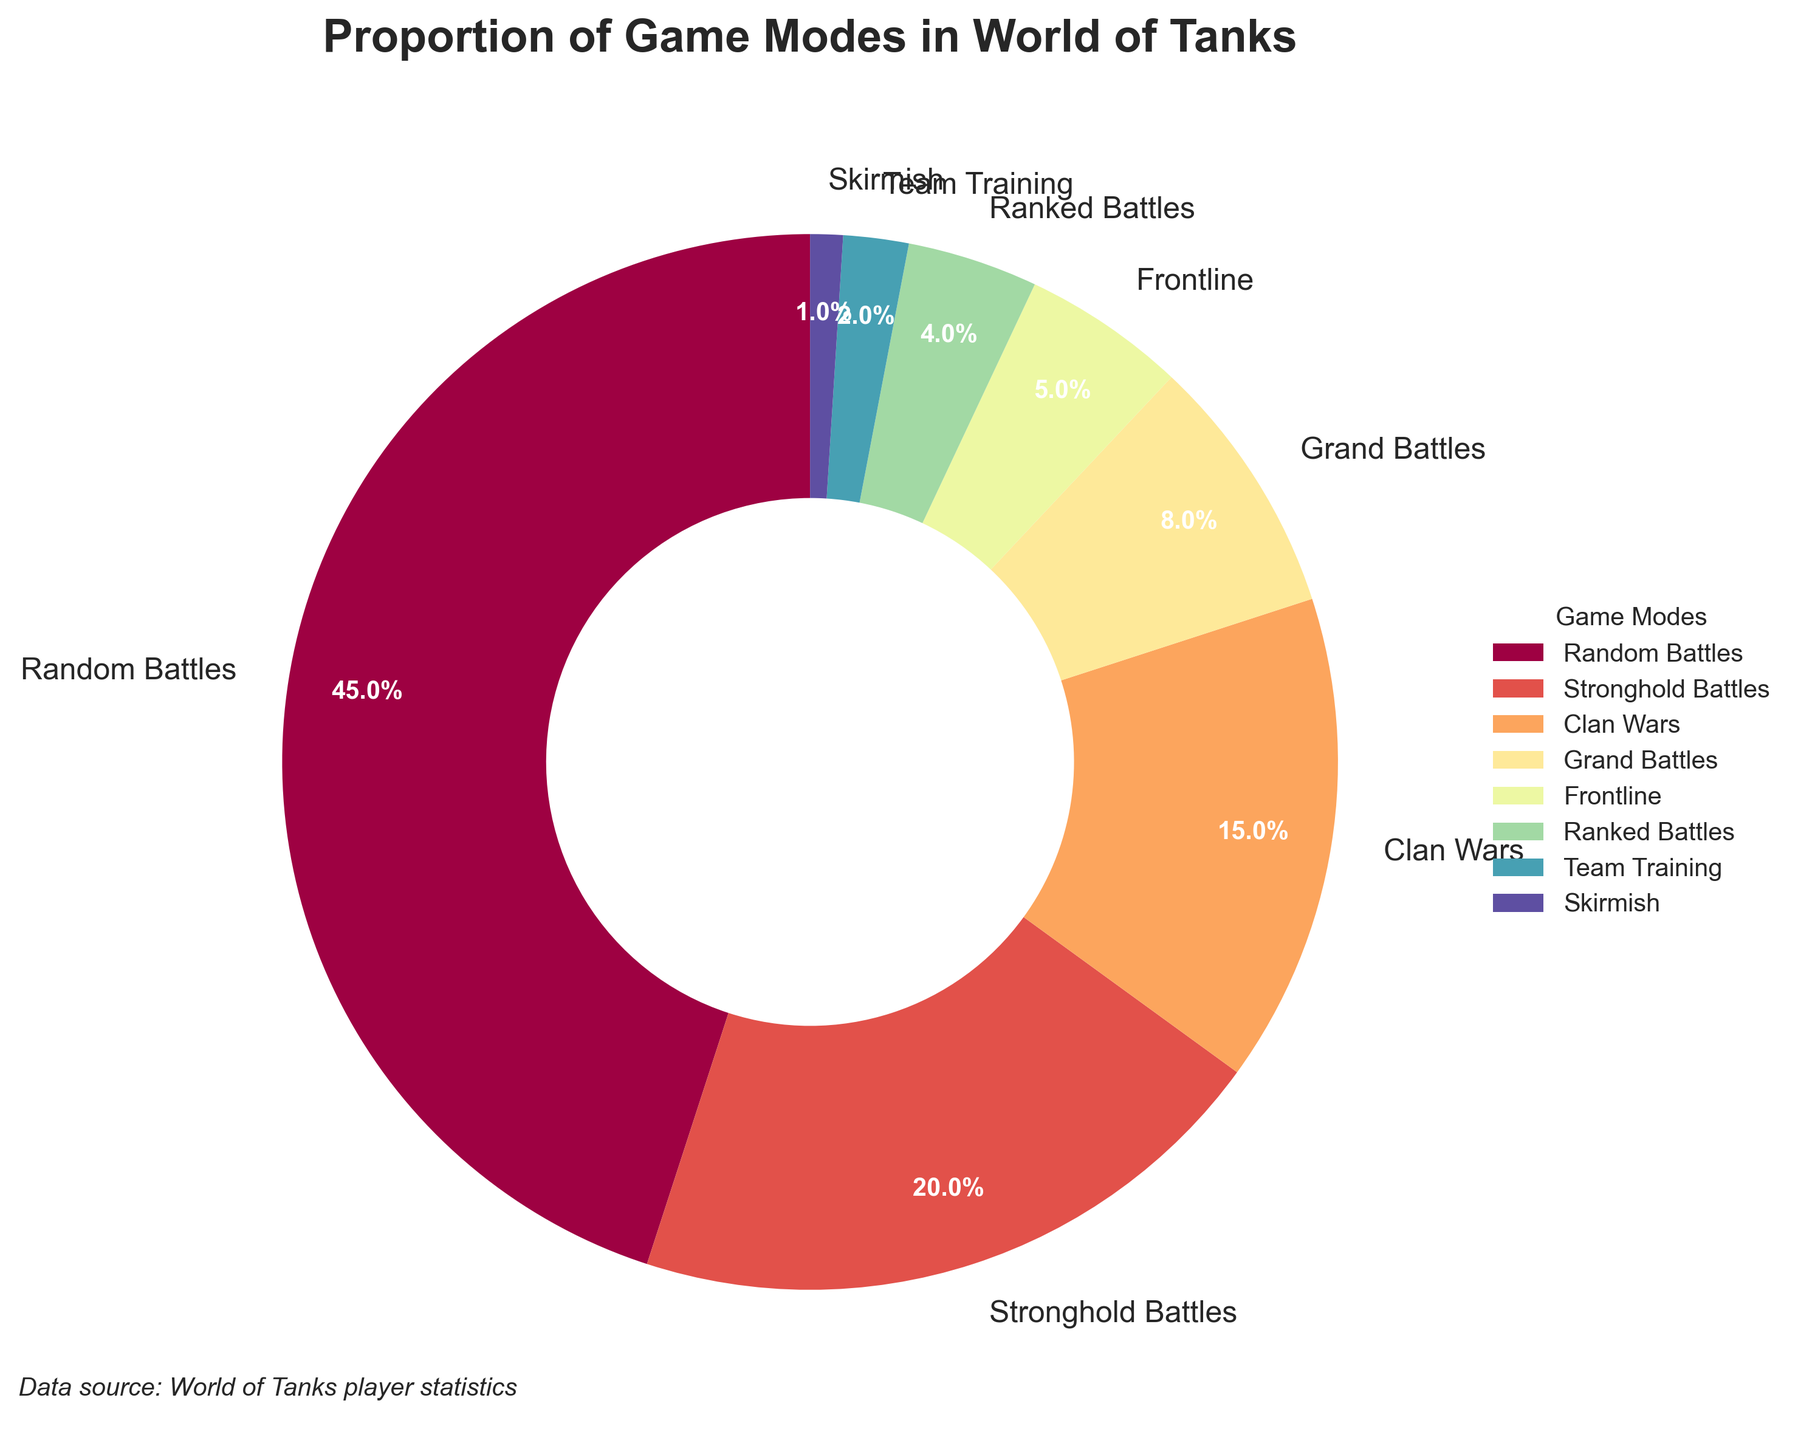What proportion of game modes does 'Random Battles' represent? The 'Random Battles' section of the pie chart represents 45% of the total game modes played. The chart shows the proportion directly.
Answer: 45% Which game mode has the smallest proportion and what is its percentage? The section of the pie chart labeled 'Skirmish' represents the smallest proportion of game modes played, which is 1%.
Answer: Skirmish, 1% How does the proportion of 'Stronghold Battles' compare to 'Clan Wars'? The 'Stronghold Battles' section represents 20% while 'Clan Wars' represents 15%. Thus, 'Stronghold Battles' account for a larger proportion than 'Clan Wars'.
Answer: Stronghold Battles > Clan Wars What is the combined percentage of 'Ranked Battles' and 'Team Training'? 'Ranked Battles' represent 4% and 'Team Training' represents 2%, so the combined percentage is 4% + 2% = 6%.
Answer: 6% If 'Random Battles' and 'Stronghold Battles' are combined, what percentage of game modes do they represent? Random Battles' represent 45% and 'Stronghold Battles' represent 20%. When combined, they represent 45% + 20% = 65%.
Answer: 65% Which game mode has a higher percentage, 'Frontline' or 'Grand Battles'? 'Grand Battles' are represented by 8% while 'Frontline' is represented by 5%. Therefore, 'Grand Battles' have a higher percentage.
Answer: Grand Battles What is the median percentage value among the game modes? The percentages are: 45, 20, 15, 8, 5, 4, 2, 1. When ordered, the middle two values are 8 and 5. The median is (8 + 5)/2 = 6.5.
Answer: 6.5% What color represents 'Random Battles' in the pie chart? In the pie chart, different game modes are represented by different colors. The 'Random Battles' section is the largest and is usually highlighted with the first color in the colormap applied, often seen in a prominent color like red or another easily distinguishable color.
Answer: Red (or prominent color) Which game modes combined make up less than 10% of the game play? 'Ranked Battles' (4%), 'Team Training' (2%), and 'Skirmish' (1%) combined sum up to 4% + 2% + 1% = 7%, which is less than 10%.
Answer: Ranked Battles, Team Training, Skirmish What percentage of game modes are neither 'Random Battles' nor 'Stronghold Battles'? 'Random Battles' and 'Stronghold Battles' combined are 45% + 20% = 65%. So, the percentage of other game modes is 100% - 65% = 35%.
Answer: 35% 